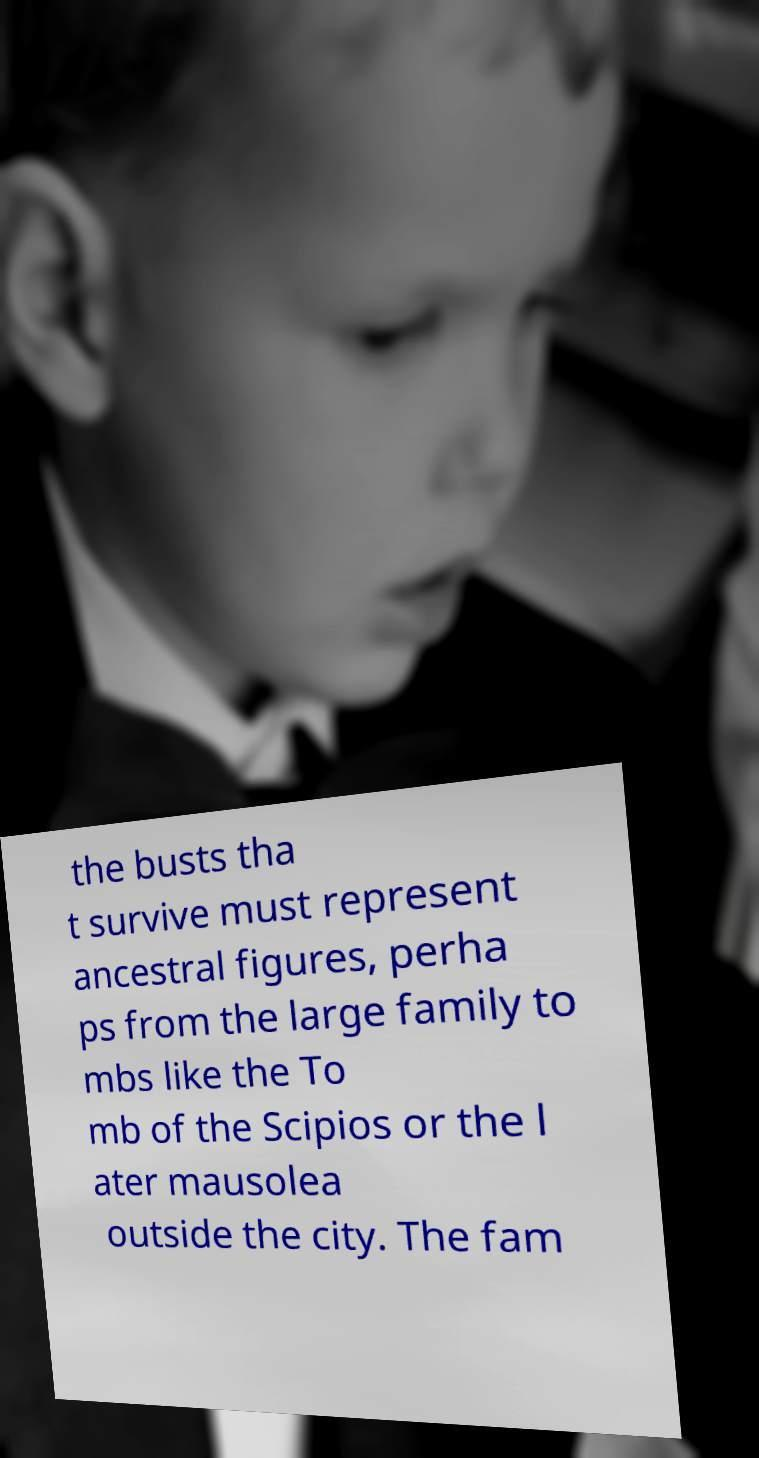I need the written content from this picture converted into text. Can you do that? the busts tha t survive must represent ancestral figures, perha ps from the large family to mbs like the To mb of the Scipios or the l ater mausolea outside the city. The fam 